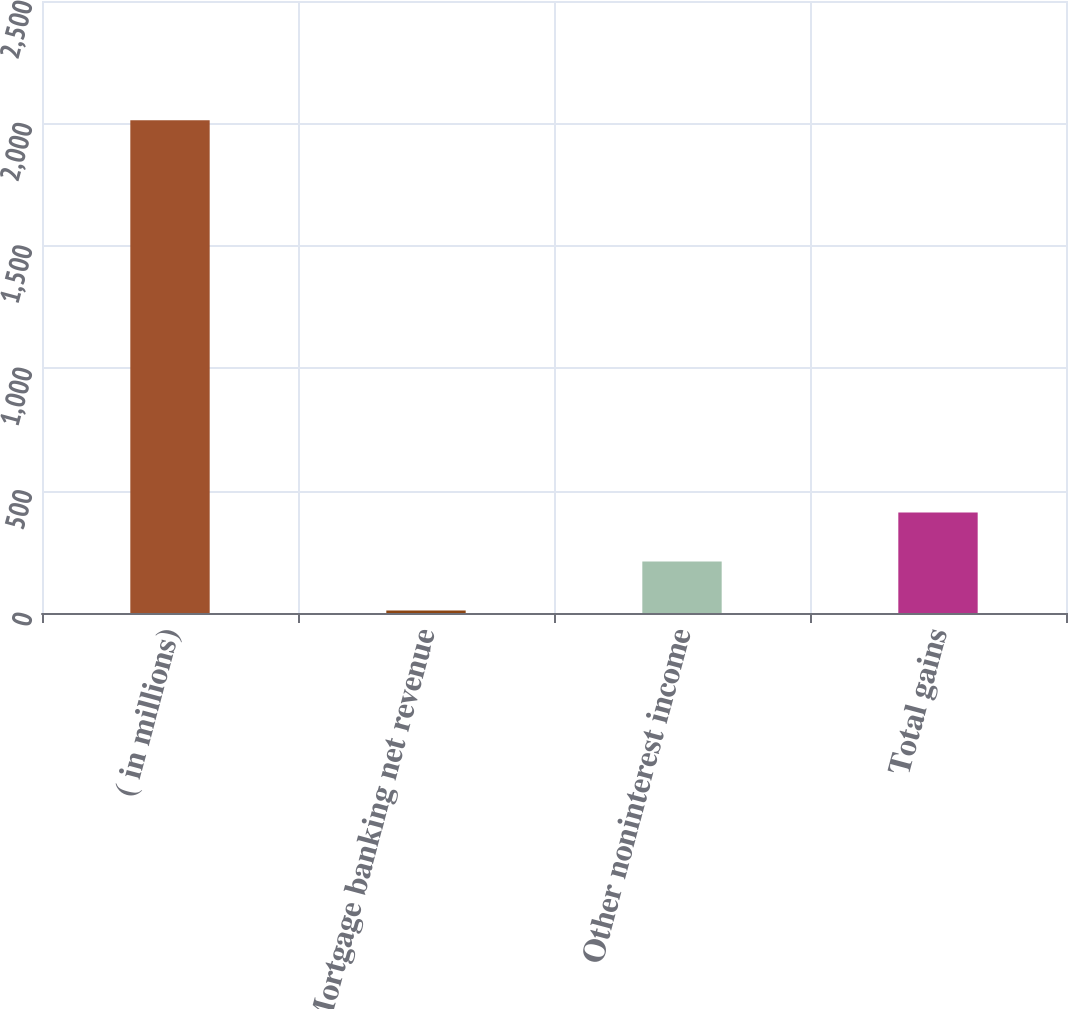Convert chart. <chart><loc_0><loc_0><loc_500><loc_500><bar_chart><fcel>( in millions)<fcel>Mortgage banking net revenue<fcel>Other noninterest income<fcel>Total gains<nl><fcel>2013<fcel>10<fcel>210.3<fcel>410.6<nl></chart> 